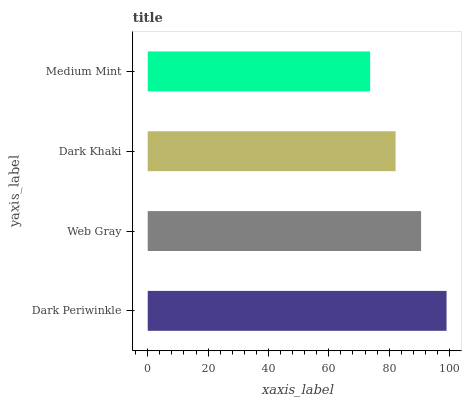Is Medium Mint the minimum?
Answer yes or no. Yes. Is Dark Periwinkle the maximum?
Answer yes or no. Yes. Is Web Gray the minimum?
Answer yes or no. No. Is Web Gray the maximum?
Answer yes or no. No. Is Dark Periwinkle greater than Web Gray?
Answer yes or no. Yes. Is Web Gray less than Dark Periwinkle?
Answer yes or no. Yes. Is Web Gray greater than Dark Periwinkle?
Answer yes or no. No. Is Dark Periwinkle less than Web Gray?
Answer yes or no. No. Is Web Gray the high median?
Answer yes or no. Yes. Is Dark Khaki the low median?
Answer yes or no. Yes. Is Medium Mint the high median?
Answer yes or no. No. Is Medium Mint the low median?
Answer yes or no. No. 